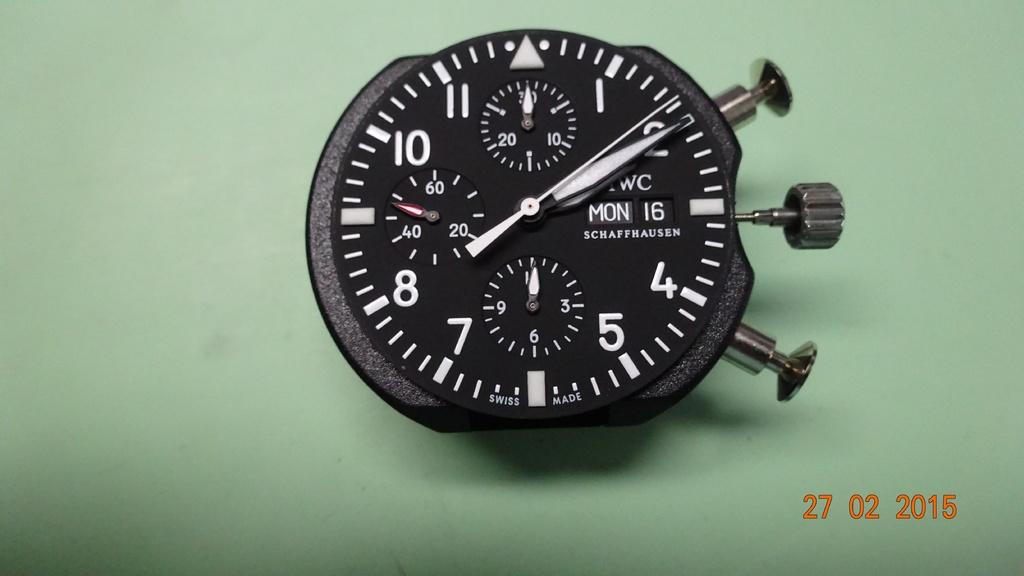<image>
Render a clear and concise summary of the photo. Face of a watch which says MON 16 on it. 